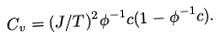Convert formula to latex. <formula><loc_0><loc_0><loc_500><loc_500>C _ { v } = ( J / T ) ^ { 2 } \phi ^ { - 1 } c ( 1 - \phi ^ { - 1 } c ) .</formula> 